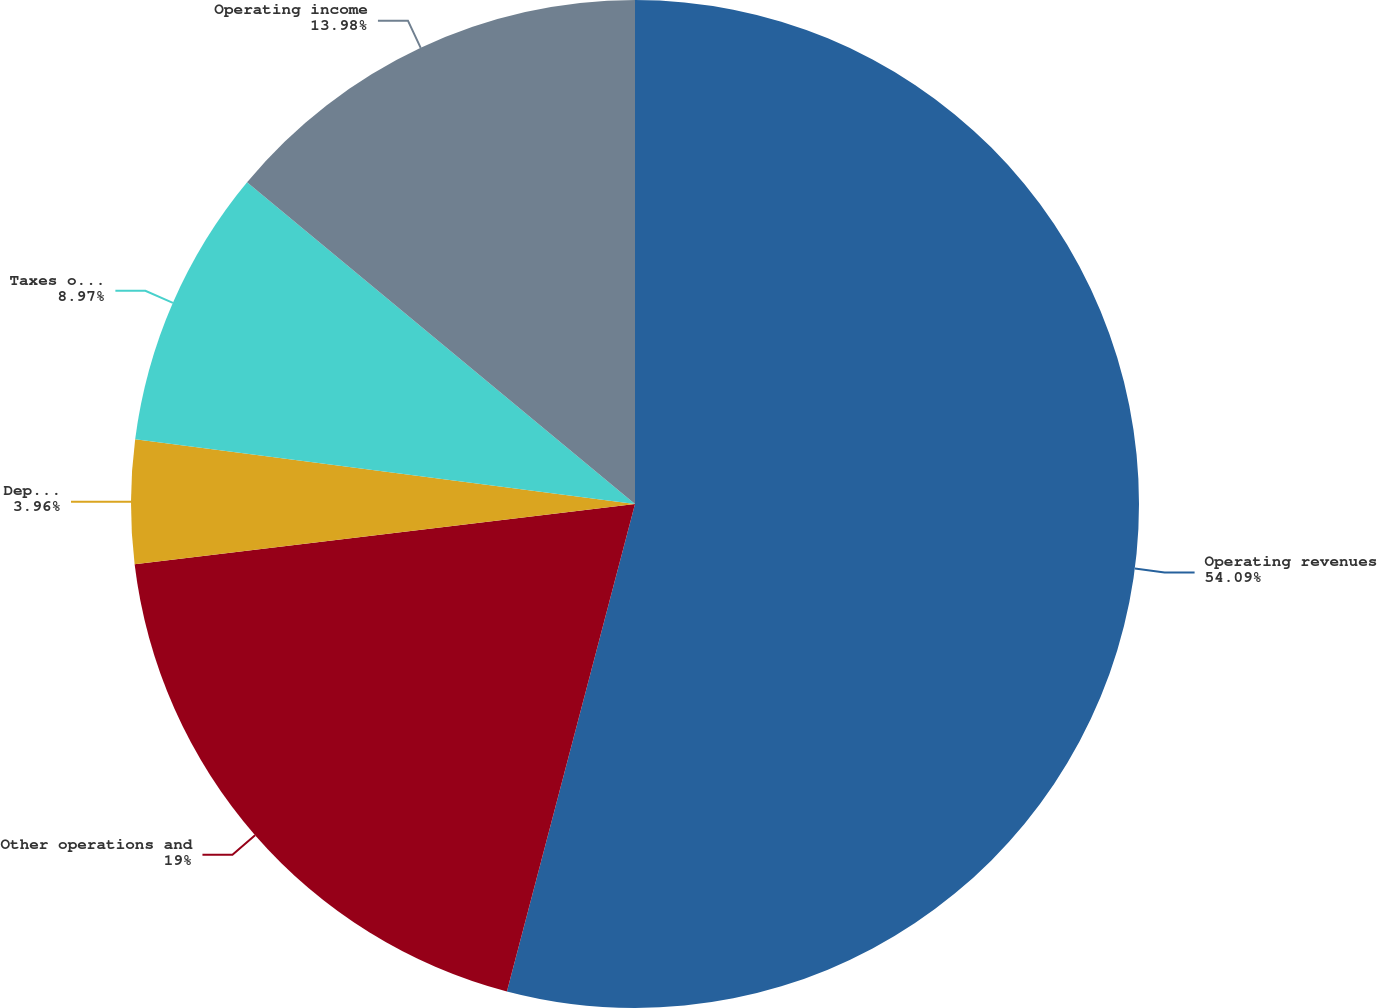Convert chart. <chart><loc_0><loc_0><loc_500><loc_500><pie_chart><fcel>Operating revenues<fcel>Other operations and<fcel>Depreciation and amortization<fcel>Taxes other than income taxes<fcel>Operating income<nl><fcel>54.09%<fcel>19.0%<fcel>3.96%<fcel>8.97%<fcel>13.98%<nl></chart> 